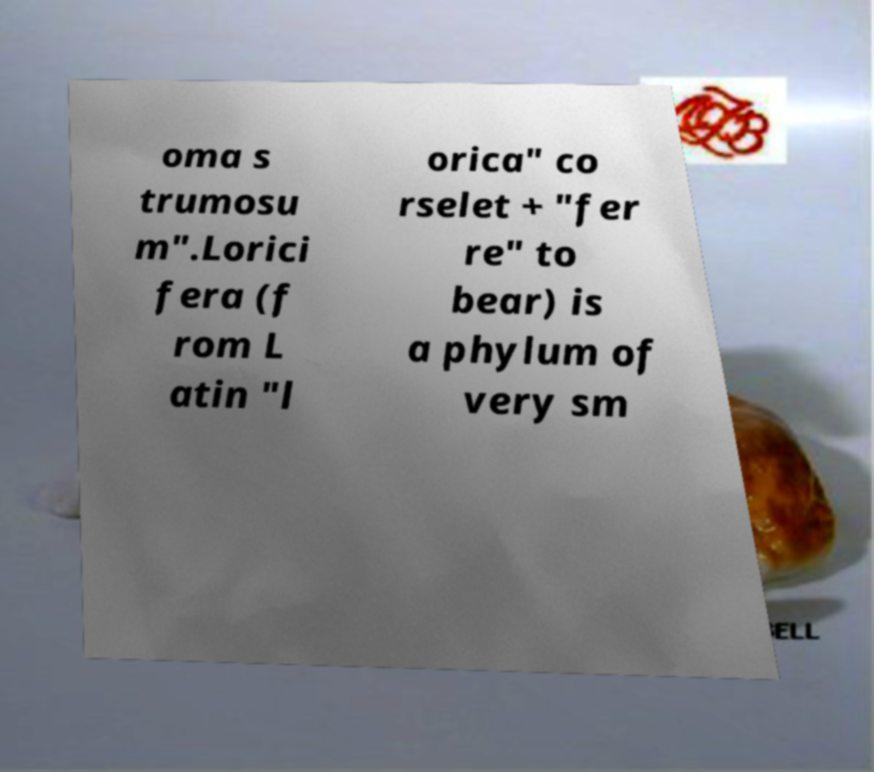Can you accurately transcribe the text from the provided image for me? oma s trumosu m".Lorici fera (f rom L atin "l orica" co rselet + "fer re" to bear) is a phylum of very sm 